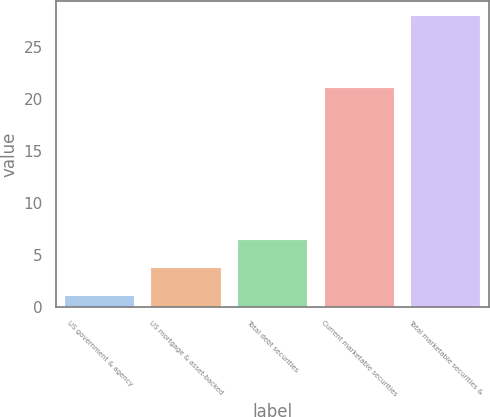<chart> <loc_0><loc_0><loc_500><loc_500><bar_chart><fcel>US government & agency<fcel>US mortgage & asset-backed<fcel>Total debt securities<fcel>Current marketable securities<fcel>Total marketable securities &<nl><fcel>1<fcel>3.7<fcel>6.4<fcel>21<fcel>28<nl></chart> 